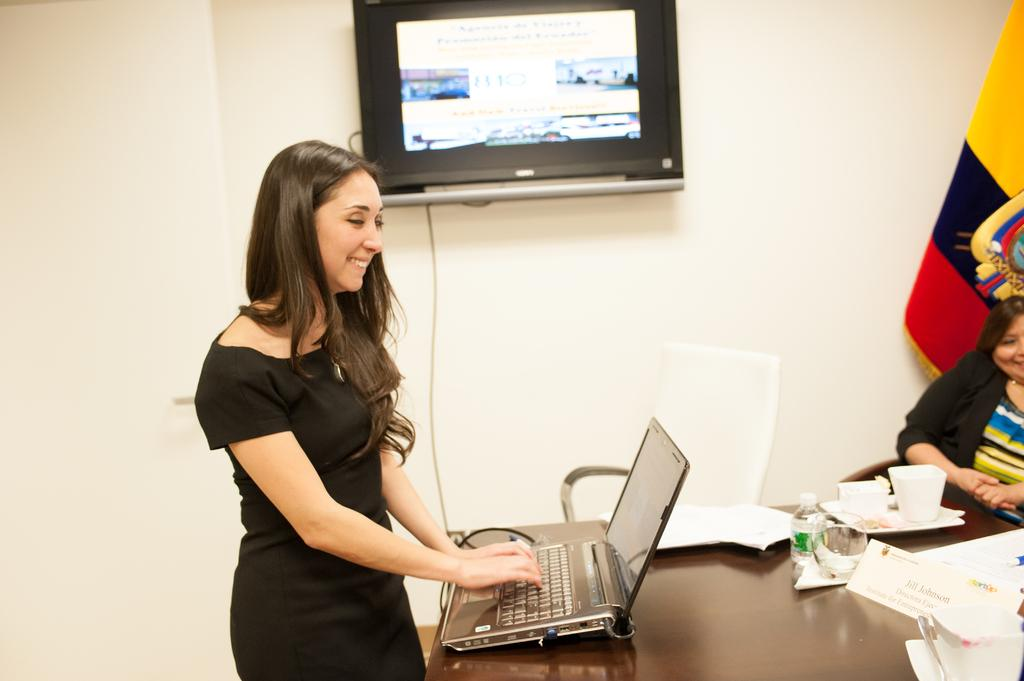What is the woman in the image wearing? The woman is wearing a black dress in the image. What is the woman doing with the laptop? The woman is operating a laptop in the image. Where is the laptop placed? The laptop is placed on a table in the image. What other electronic device is present in the image? There is a television beside the table in the image. Can you describe the other person in the image? There is another person sitting in the right corner of the image. How many chickens are visible in the image? There are no chickens present in the image. What type of flesh is being consumed by the woman in the image? There is no indication of any food, let alone flesh, being consumed in the image. 